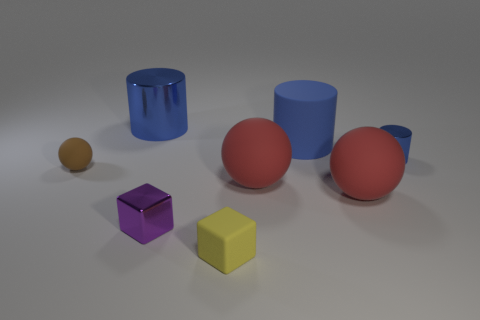Subtract all brown cylinders. How many red spheres are left? 2 Subtract all red spheres. How many spheres are left? 1 Subtract 1 spheres. How many spheres are left? 2 Add 1 yellow matte things. How many objects exist? 9 Subtract all blocks. How many objects are left? 6 Subtract all gray balls. Subtract all cyan cylinders. How many balls are left? 3 Add 7 small purple matte cylinders. How many small purple matte cylinders exist? 7 Subtract 0 gray cylinders. How many objects are left? 8 Subtract all big brown metallic balls. Subtract all large blue matte objects. How many objects are left? 7 Add 3 yellow rubber objects. How many yellow rubber objects are left? 4 